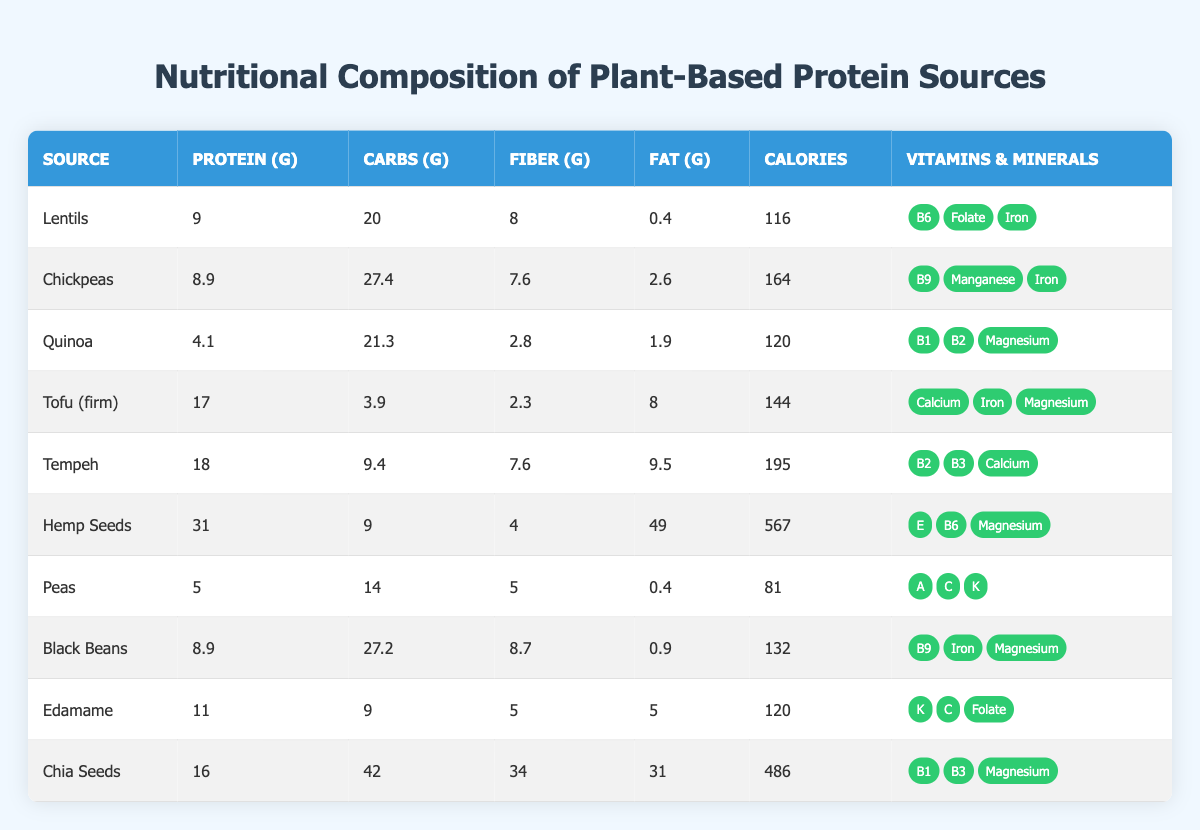What is the protein content of Tempeh? In the table, locate the row for Tempeh. The protein content listed next to Tempeh is 18 grams.
Answer: 18 grams Which plant protein source has the lowest carbohydrate content? By reviewing the carbohydrate values from each source, Peas has the lowest carbohydrate content with 14 grams.
Answer: Peas What is the total fiber content in Lentils and Black Beans combined? For Lentils, the fiber content is 8 grams, and for Black Beans, it is 8.7 grams. Adding them together: 8 + 8.7 = 16.7 grams of fiber.
Answer: 16.7 grams True or False: Quinoa contains higher protein than Edamame. Quinoa has 4.1 grams of protein and Edamame has 11 grams. Therefore, the statement is false.
Answer: False What is the calorie difference between Hemp Seeds and Tofu (firm)? Hemp Seeds have 567 calories, and Tofu (firm) has 144 calories. The difference is calculated as 567 - 144 = 423 calories.
Answer: 423 calories Which vitamin is present in the highest number of plant protein sources? By inspecting the vitamins listed for each source, we find B6 appears in Three sources (Lentils, Hemp Seeds, and Tofu). However, B9 also appears in Chickpeas and Black Beans, making it common across four sources. Thus, B9 is present in the highest number of sources.
Answer: B9 If you were to average the protein content of all sources listed, what would that average be? The total protein content from all sources is summed: 9 + 8.9 + 4.1 + 17 + 18 + 31 + 5 + 8.9 + 11 + 16 = 129.1 grams. There are 10 sources, so the average protein content is 129.1 / 10 = 12.91 grams.
Answer: 12.91 grams Which source has the highest fat content and what is the value? By scanning the fat values, Hemp Seeds shows the highest content at 49 grams.
Answer: 49 grams Does Chickpeas provide more calories than Black Beans? Chickpeas have 164 calories and Black Beans have 132 calories, which means Chickpeas provide more calories.
Answer: Yes 